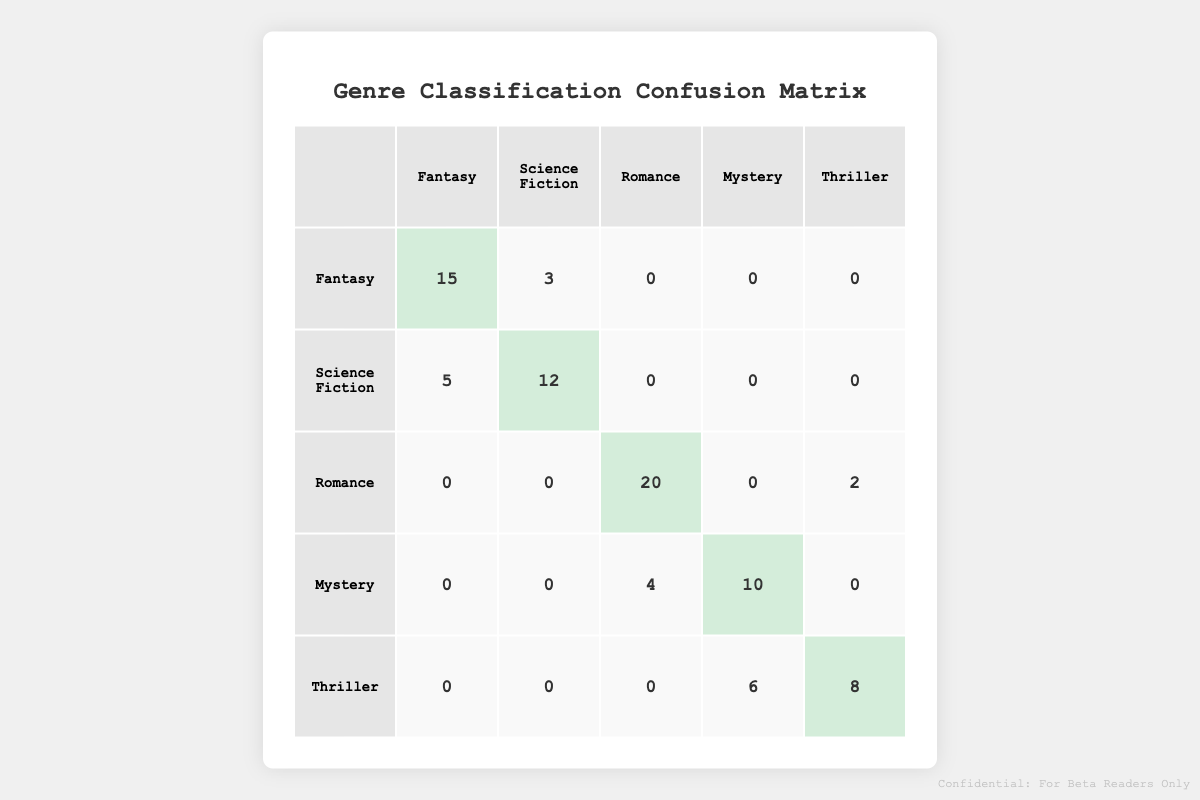What is the total number of manuscripts classified as Fantasy? There are 15 manuscripts classified as Fantasy that were predicted correctly, and 3 that were incorrectly predicted as Science Fiction. The total is therefore 15 + 3 = 18.
Answer: 18 How many manuscripts were incorrectly classified as Romance? In the table, Romance has 2 manuscripts classified as Thriller and 4 classified as Mystery. When you sum these, you get 2 + 4 = 6.
Answer: 6 What is the total number of predictions made for Mysteries? For Mysteries, 10 were correctly predicted as Mystery, and 4 were incorrectly predicted as Romance. Therefore, the total is 10 + 4 = 14.
Answer: 14 Is the count of manuscripts classified as Thriller greater than the sum of those classified as Fantasy and Science Fiction? The count for Thriller is 8 (correctly predicted) + 6 (incorrectly as Mystery), totaling 14. The sum for Fantasy (15 + 3) is 18, while for Science Fiction (12 + 5) is 17. Since 14 is less than 18 + 17 = 35, the statement is false.
Answer: No What percentage of the manuscripts classified as Romance were predicted correctly? There are a total of 20 manuscripts classified as Romance, with 20 predicted correctly. The percentage is therefore (20 / 20) * 100 = 100%.
Answer: 100% What is the difference in the number of manuscripts between the correct classifications of Science Fiction and Thriller? For Science Fiction, the correct count is 12, and for Thriller, it's 8. The difference is 12 - 8 = 4.
Answer: 4 How many manuscripts in total were classified as Science Fiction? A total of 12 were classified correctly as Science Fiction and 5 were incorrectly predicted as Fantasy. Adding these gives 12 + 5 = 17.
Answer: 17 How many manuscripts were predicted as Fantasy but are actually Science Fiction? There are 5 manuscripts predicted as Fantasy that are actually Science Fiction as indicated in the table.
Answer: 5 Is there any genre that has no manuscripts predicted incorrectly? Looking at the table, Fantasy and Romance each have at least one manuscript incorrectly classified (3 and 2 respectively). Therefore, there are no genres with zero incorrect predictions.
Answer: No 